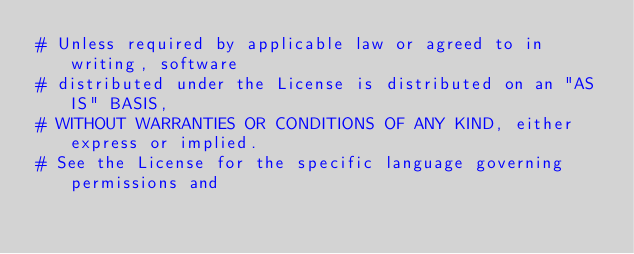<code> <loc_0><loc_0><loc_500><loc_500><_YAML_># Unless required by applicable law or agreed to in writing, software
# distributed under the License is distributed on an "AS IS" BASIS,
# WITHOUT WARRANTIES OR CONDITIONS OF ANY KIND, either express or implied.
# See the License for the specific language governing permissions and</code> 